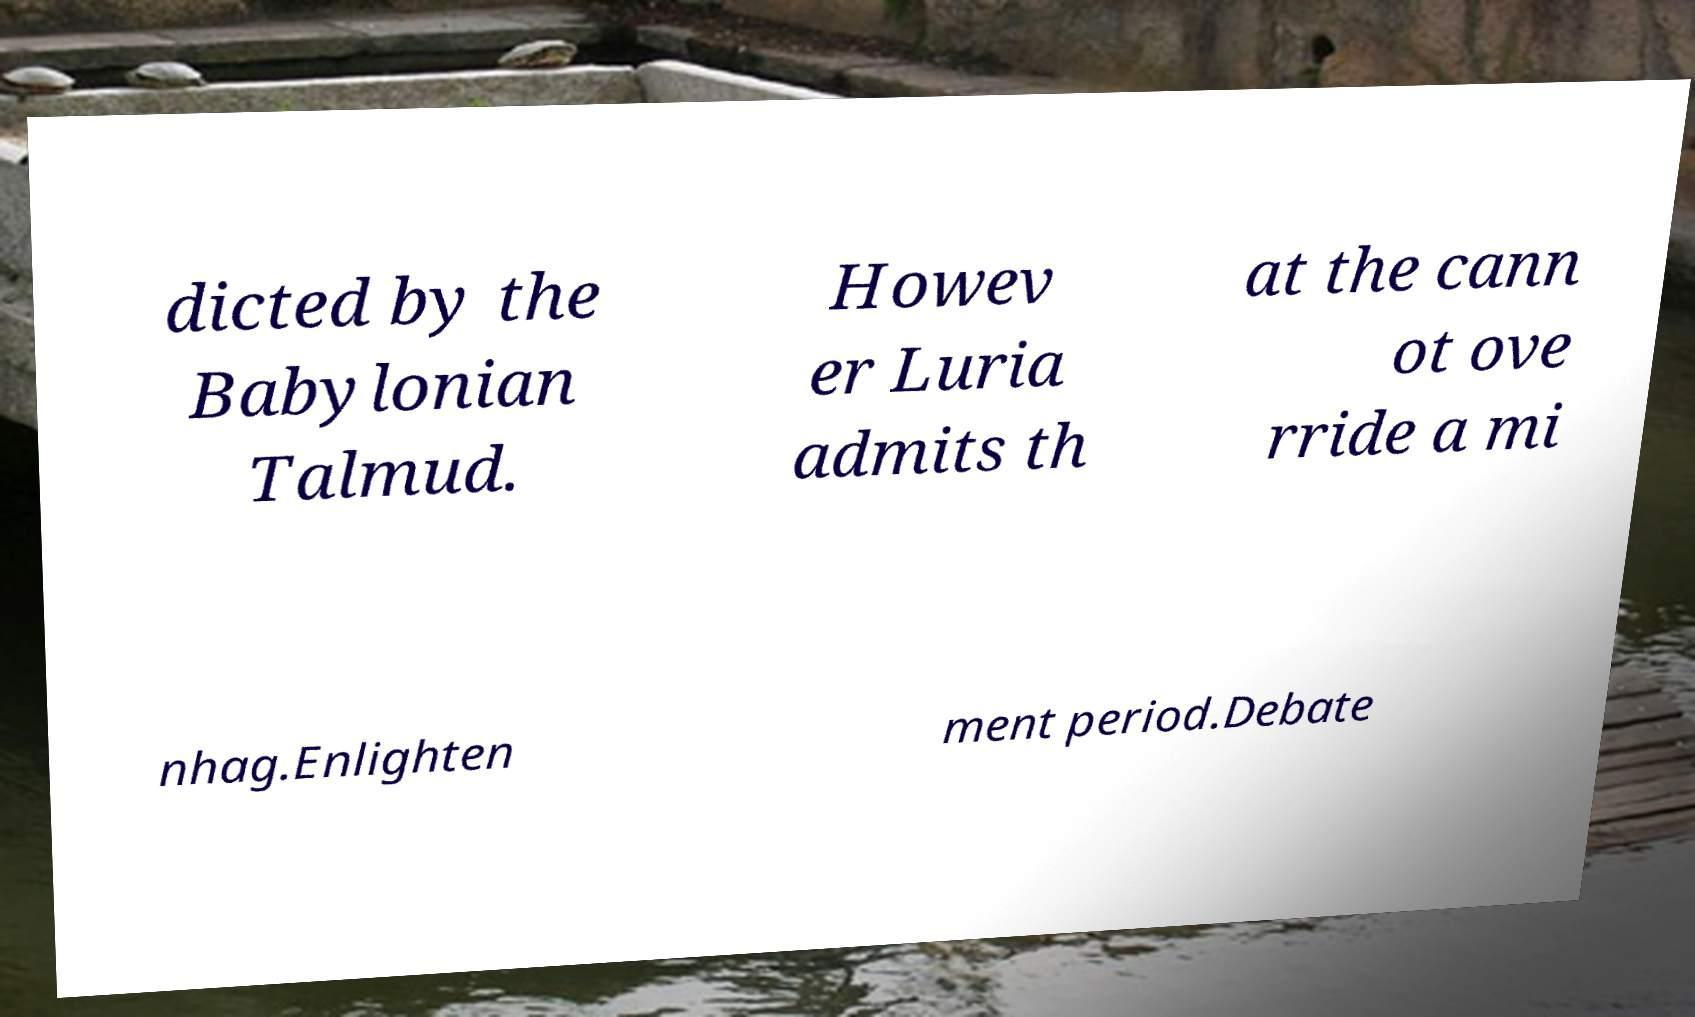There's text embedded in this image that I need extracted. Can you transcribe it verbatim? dicted by the Babylonian Talmud. Howev er Luria admits th at the cann ot ove rride a mi nhag.Enlighten ment period.Debate 